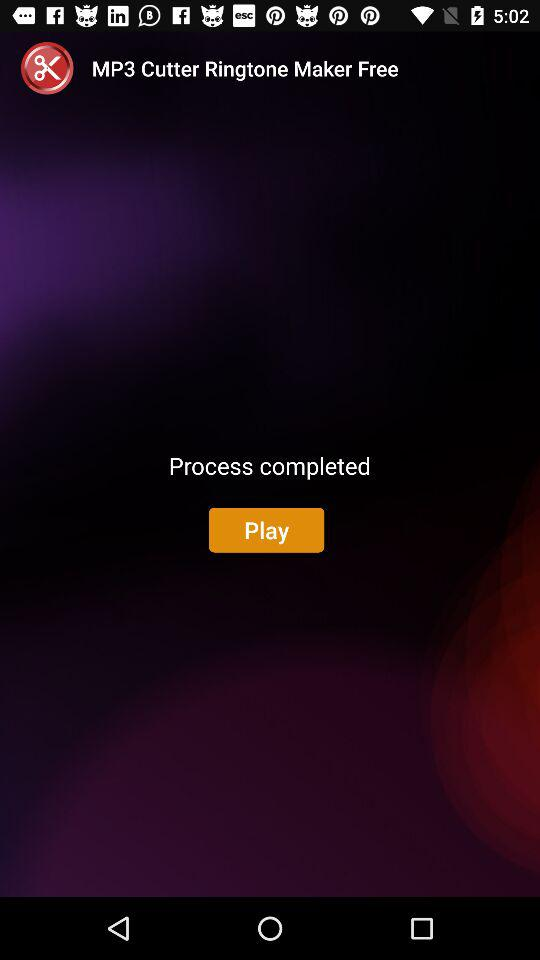What is the application name? The application name is "MP3 Cutter Ringtone Maker ". 